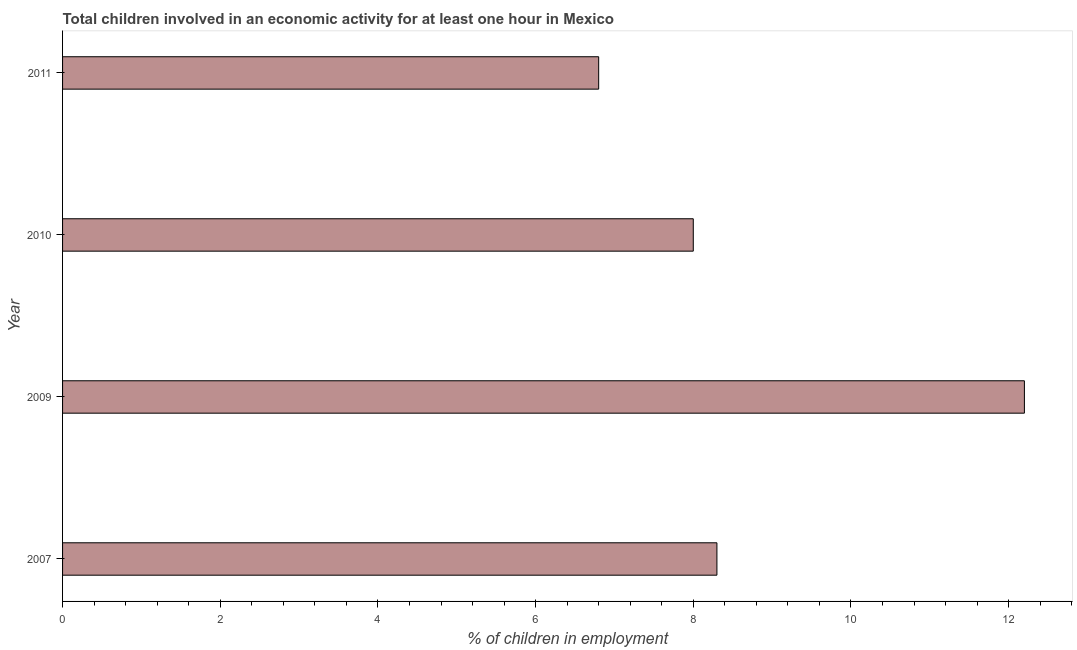Does the graph contain any zero values?
Offer a terse response. No. What is the title of the graph?
Keep it short and to the point. Total children involved in an economic activity for at least one hour in Mexico. What is the label or title of the X-axis?
Your response must be concise. % of children in employment. What is the percentage of children in employment in 2007?
Give a very brief answer. 8.3. In which year was the percentage of children in employment minimum?
Ensure brevity in your answer.  2011. What is the sum of the percentage of children in employment?
Ensure brevity in your answer.  35.3. What is the average percentage of children in employment per year?
Provide a succinct answer. 8.82. What is the median percentage of children in employment?
Your response must be concise. 8.15. In how many years, is the percentage of children in employment greater than 0.4 %?
Your response must be concise. 4. What is the ratio of the percentage of children in employment in 2007 to that in 2011?
Your answer should be very brief. 1.22. Is the percentage of children in employment in 2009 less than that in 2011?
Your answer should be compact. No. Is the difference between the percentage of children in employment in 2010 and 2011 greater than the difference between any two years?
Offer a terse response. No. What is the difference between the highest and the lowest percentage of children in employment?
Make the answer very short. 5.4. How many years are there in the graph?
Your answer should be compact. 4. What is the % of children in employment in 2007?
Offer a very short reply. 8.3. What is the % of children in employment in 2009?
Your answer should be compact. 12.2. What is the % of children in employment of 2010?
Give a very brief answer. 8. What is the difference between the % of children in employment in 2007 and 2010?
Ensure brevity in your answer.  0.3. What is the difference between the % of children in employment in 2007 and 2011?
Make the answer very short. 1.5. What is the difference between the % of children in employment in 2009 and 2010?
Give a very brief answer. 4.2. What is the difference between the % of children in employment in 2010 and 2011?
Provide a short and direct response. 1.2. What is the ratio of the % of children in employment in 2007 to that in 2009?
Offer a terse response. 0.68. What is the ratio of the % of children in employment in 2007 to that in 2010?
Your response must be concise. 1.04. What is the ratio of the % of children in employment in 2007 to that in 2011?
Keep it short and to the point. 1.22. What is the ratio of the % of children in employment in 2009 to that in 2010?
Ensure brevity in your answer.  1.52. What is the ratio of the % of children in employment in 2009 to that in 2011?
Make the answer very short. 1.79. What is the ratio of the % of children in employment in 2010 to that in 2011?
Offer a very short reply. 1.18. 